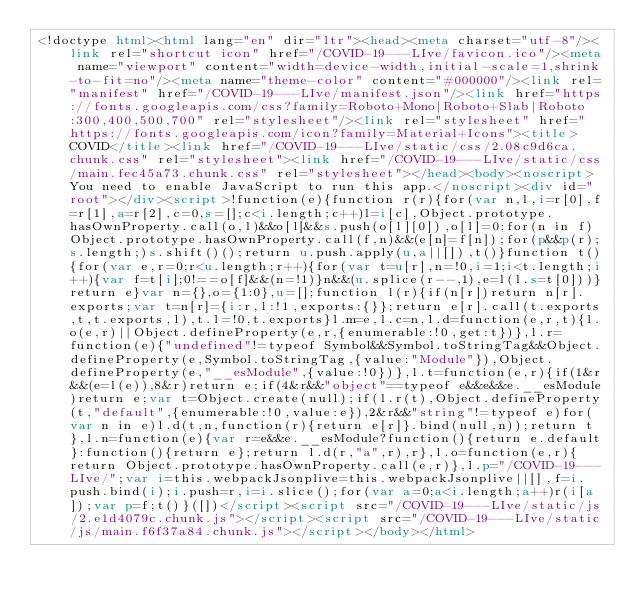Convert code to text. <code><loc_0><loc_0><loc_500><loc_500><_HTML_><!doctype html><html lang="en" dir="ltr"><head><meta charset="utf-8"/><link rel="shortcut icon" href="/COVID-19---LIve/favicon.ico"/><meta name="viewport" content="width=device-width,initial-scale=1,shrink-to-fit=no"/><meta name="theme-color" content="#000000"/><link rel="manifest" href="/COVID-19---LIve/manifest.json"/><link href="https://fonts.googleapis.com/css?family=Roboto+Mono|Roboto+Slab|Roboto:300,400,500,700" rel="stylesheet"/><link rel="stylesheet" href="https://fonts.googleapis.com/icon?family=Material+Icons"><title>COVID</title><link href="/COVID-19---LIve/static/css/2.08c9d6ca.chunk.css" rel="stylesheet"><link href="/COVID-19---LIve/static/css/main.fec45a73.chunk.css" rel="stylesheet"></head><body><noscript>You need to enable JavaScript to run this app.</noscript><div id="root"></div><script>!function(e){function r(r){for(var n,l,i=r[0],f=r[1],a=r[2],c=0,s=[];c<i.length;c++)l=i[c],Object.prototype.hasOwnProperty.call(o,l)&&o[l]&&s.push(o[l][0]),o[l]=0;for(n in f)Object.prototype.hasOwnProperty.call(f,n)&&(e[n]=f[n]);for(p&&p(r);s.length;)s.shift()();return u.push.apply(u,a||[]),t()}function t(){for(var e,r=0;r<u.length;r++){for(var t=u[r],n=!0,i=1;i<t.length;i++){var f=t[i];0!==o[f]&&(n=!1)}n&&(u.splice(r--,1),e=l(l.s=t[0]))}return e}var n={},o={1:0},u=[];function l(r){if(n[r])return n[r].exports;var t=n[r]={i:r,l:!1,exports:{}};return e[r].call(t.exports,t,t.exports,l),t.l=!0,t.exports}l.m=e,l.c=n,l.d=function(e,r,t){l.o(e,r)||Object.defineProperty(e,r,{enumerable:!0,get:t})},l.r=function(e){"undefined"!=typeof Symbol&&Symbol.toStringTag&&Object.defineProperty(e,Symbol.toStringTag,{value:"Module"}),Object.defineProperty(e,"__esModule",{value:!0})},l.t=function(e,r){if(1&r&&(e=l(e)),8&r)return e;if(4&r&&"object"==typeof e&&e&&e.__esModule)return e;var t=Object.create(null);if(l.r(t),Object.defineProperty(t,"default",{enumerable:!0,value:e}),2&r&&"string"!=typeof e)for(var n in e)l.d(t,n,function(r){return e[r]}.bind(null,n));return t},l.n=function(e){var r=e&&e.__esModule?function(){return e.default}:function(){return e};return l.d(r,"a",r),r},l.o=function(e,r){return Object.prototype.hasOwnProperty.call(e,r)},l.p="/COVID-19---LIve/";var i=this.webpackJsonplive=this.webpackJsonplive||[],f=i.push.bind(i);i.push=r,i=i.slice();for(var a=0;a<i.length;a++)r(i[a]);var p=f;t()}([])</script><script src="/COVID-19---LIve/static/js/2.e1d4079c.chunk.js"></script><script src="/COVID-19---LIve/static/js/main.f6f37a84.chunk.js"></script></body></html></code> 